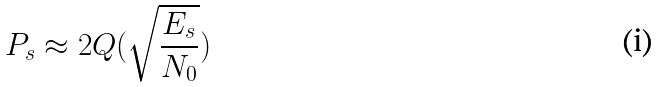Convert formula to latex. <formula><loc_0><loc_0><loc_500><loc_500>P _ { s } \approx 2 Q ( \sqrt { \frac { E _ { s } } { N _ { 0 } } } )</formula> 